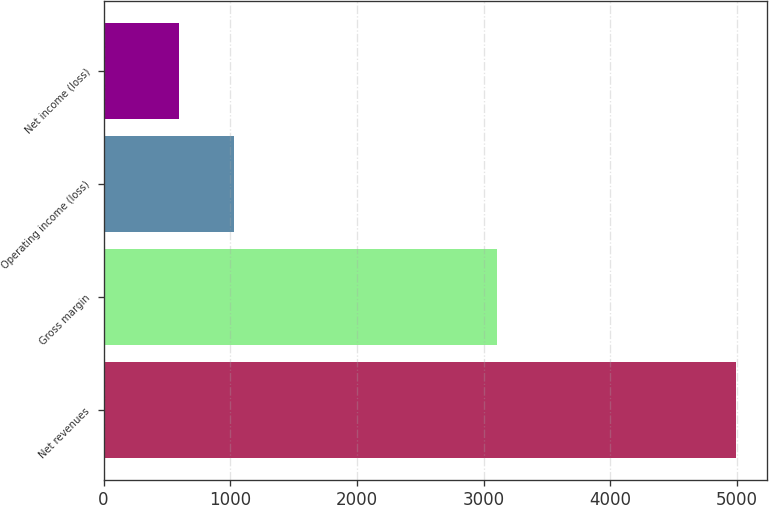Convert chart to OTSL. <chart><loc_0><loc_0><loc_500><loc_500><bar_chart><fcel>Net revenues<fcel>Gross margin<fcel>Operating income (loss)<fcel>Net income (loss)<nl><fcel>4990.1<fcel>3104.5<fcel>1032.44<fcel>592.7<nl></chart> 